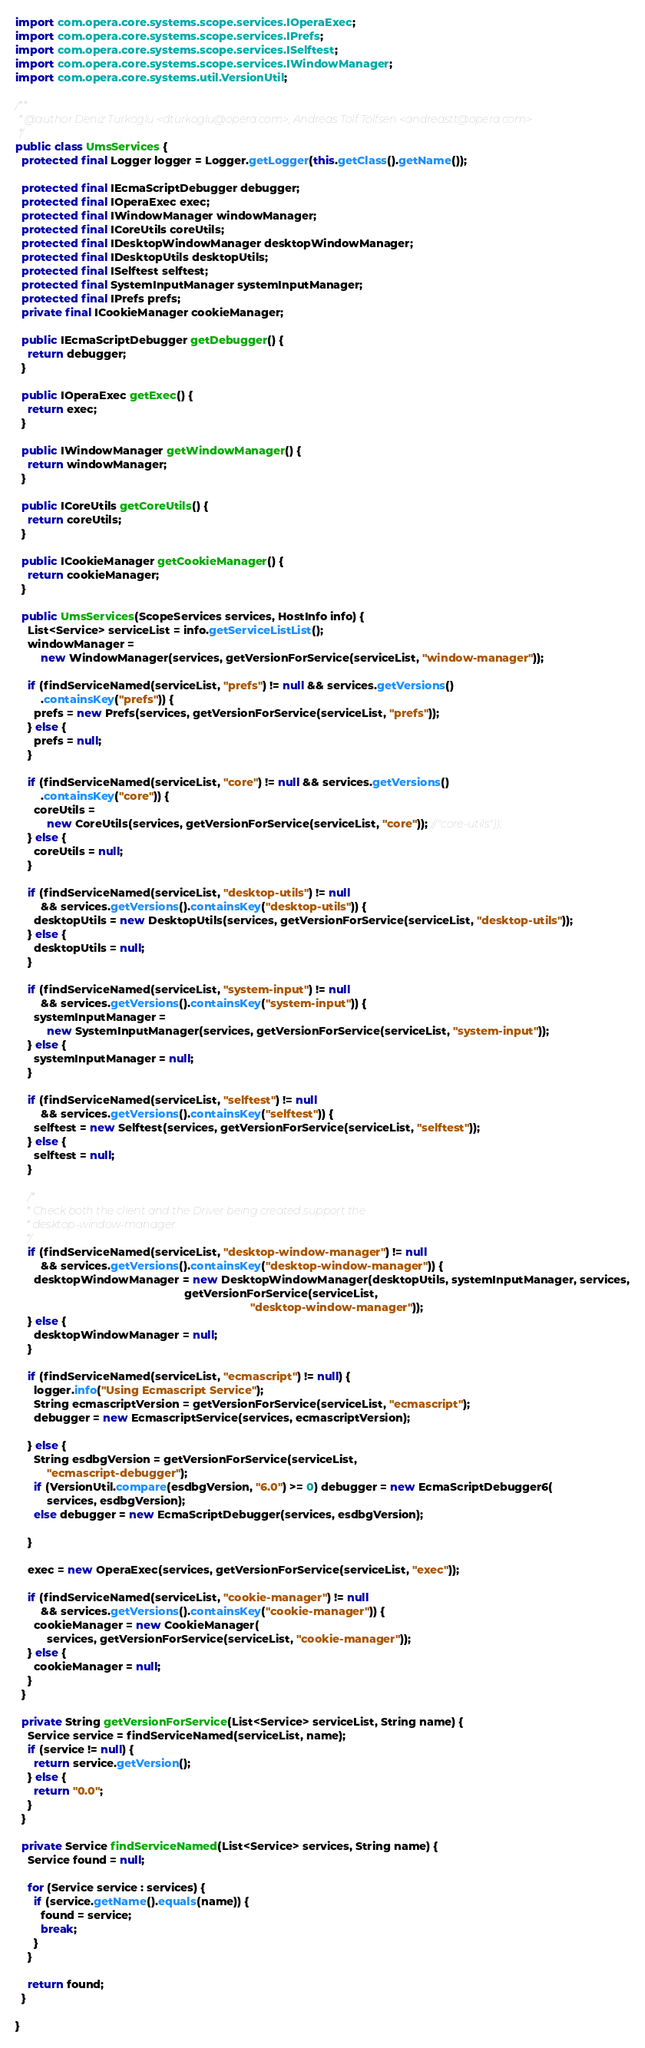<code> <loc_0><loc_0><loc_500><loc_500><_Java_>import com.opera.core.systems.scope.services.IOperaExec;
import com.opera.core.systems.scope.services.IPrefs;
import com.opera.core.systems.scope.services.ISelftest;
import com.opera.core.systems.scope.services.IWindowManager;
import com.opera.core.systems.util.VersionUtil;

/**
 * @author Deniz Turkoglu <dturkoglu@opera.com>, Andreas Tolf Tolfsen <andreastt@opera.com>
 */
public class UmsServices {
  protected final Logger logger = Logger.getLogger(this.getClass().getName());

  protected final IEcmaScriptDebugger debugger;
  protected final IOperaExec exec;
  protected final IWindowManager windowManager;
  protected final ICoreUtils coreUtils;
  protected final IDesktopWindowManager desktopWindowManager;
  protected final IDesktopUtils desktopUtils;
  protected final ISelftest selftest;
  protected final SystemInputManager systemInputManager;
  protected final IPrefs prefs;
  private final ICookieManager cookieManager;

  public IEcmaScriptDebugger getDebugger() {
    return debugger;
  }

  public IOperaExec getExec() {
    return exec;
  }

  public IWindowManager getWindowManager() {
    return windowManager;
  }

  public ICoreUtils getCoreUtils() {
    return coreUtils;
  }

  public ICookieManager getCookieManager() {
    return cookieManager;
  }

  public UmsServices(ScopeServices services, HostInfo info) {
    List<Service> serviceList = info.getServiceListList();
    windowManager =
        new WindowManager(services, getVersionForService(serviceList, "window-manager"));

    if (findServiceNamed(serviceList, "prefs") != null && services.getVersions()
        .containsKey("prefs")) {
      prefs = new Prefs(services, getVersionForService(serviceList, "prefs"));
    } else {
      prefs = null;
    }

    if (findServiceNamed(serviceList, "core") != null && services.getVersions()
        .containsKey("core")) {
      coreUtils =
          new CoreUtils(services, getVersionForService(serviceList, "core")); //"core-utils"));
    } else {
      coreUtils = null;
    }

    if (findServiceNamed(serviceList, "desktop-utils") != null
        && services.getVersions().containsKey("desktop-utils")) {
      desktopUtils = new DesktopUtils(services, getVersionForService(serviceList, "desktop-utils"));
    } else {
      desktopUtils = null;
    }

    if (findServiceNamed(serviceList, "system-input") != null
        && services.getVersions().containsKey("system-input")) {
      systemInputManager =
          new SystemInputManager(services, getVersionForService(serviceList, "system-input"));
    } else {
      systemInputManager = null;
    }

    if (findServiceNamed(serviceList, "selftest") != null
        && services.getVersions().containsKey("selftest")) {
      selftest = new Selftest(services, getVersionForService(serviceList, "selftest"));
    } else {
      selftest = null;
    }

    /*
    * Check both the client and the Driver being created support the
    * desktop-window-manager
    */
    if (findServiceNamed(serviceList, "desktop-window-manager") != null
        && services.getVersions().containsKey("desktop-window-manager")) {
      desktopWindowManager = new DesktopWindowManager(desktopUtils, systemInputManager, services,
                                                      getVersionForService(serviceList,
                                                                           "desktop-window-manager"));
    } else {
      desktopWindowManager = null;
    }

    if (findServiceNamed(serviceList, "ecmascript") != null) {
      logger.info("Using Ecmascript Service");
      String ecmascriptVersion = getVersionForService(serviceList, "ecmascript");
      debugger = new EcmascriptService(services, ecmascriptVersion);

    } else {
      String esdbgVersion = getVersionForService(serviceList,
          "ecmascript-debugger");
      if (VersionUtil.compare(esdbgVersion, "6.0") >= 0) debugger = new EcmaScriptDebugger6(
          services, esdbgVersion);
      else debugger = new EcmaScriptDebugger(services, esdbgVersion);

    }

    exec = new OperaExec(services, getVersionForService(serviceList, "exec"));

    if (findServiceNamed(serviceList, "cookie-manager") != null
        && services.getVersions().containsKey("cookie-manager")) {
      cookieManager = new CookieManager(
          services, getVersionForService(serviceList, "cookie-manager"));
    } else {
      cookieManager = null;
    }
  }

  private String getVersionForService(List<Service> serviceList, String name) {
    Service service = findServiceNamed(serviceList, name);
    if (service != null) {
      return service.getVersion();
    } else {
      return "0.0";
    }
  }

  private Service findServiceNamed(List<Service> services, String name) {
    Service found = null;

    for (Service service : services) {
      if (service.getName().equals(name)) {
        found = service;
        break;
      }
    }

    return found;
  }

}</code> 